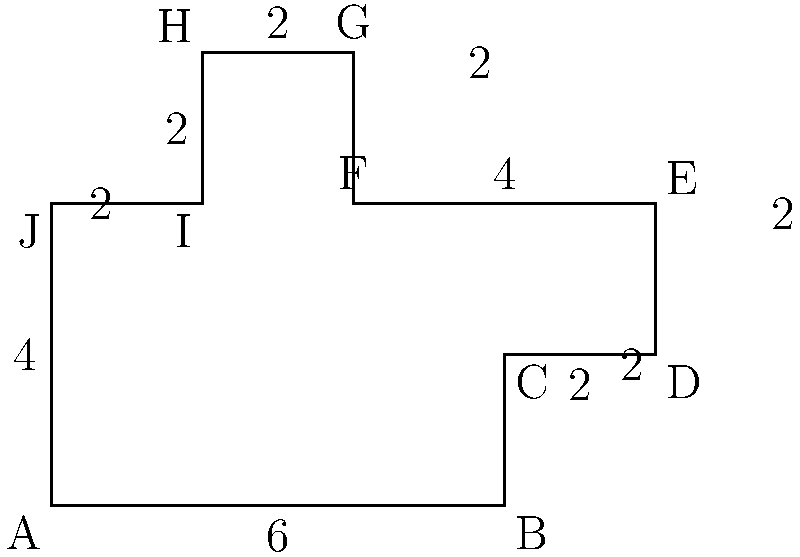In the shadowy realm of Edgar Allan Poe's imagination, a haunted mansion's floor plan takes the shape of an irregular decagon, as shown in the figure. If each unit in the diagram represents 5 meters, calculate the perimeter of this eerie abode, where countless ravens have found refuge over the centuries. To calculate the perimeter of this haunted mansion, we need to sum up the lengths of all sides and then multiply by the scale factor. Let's proceed step by step:

1) Sum up the lengths of all sides:
   - Bottom: 6 units
   - Right side: 2 + 2 + 2 = 6 units
   - Top: 4 + 2 = 6 units
   - Left side: 2 + 2 + 4 = 8 units

2) Total length in units:
   $6 + 6 + 6 + 8 = 26$ units

3) Convert units to meters:
   Each unit represents 5 meters, so we multiply:
   $26 \times 5 = 130$ meters

Therefore, the perimeter of the haunted mansion is 130 meters.
Answer: 130 meters 